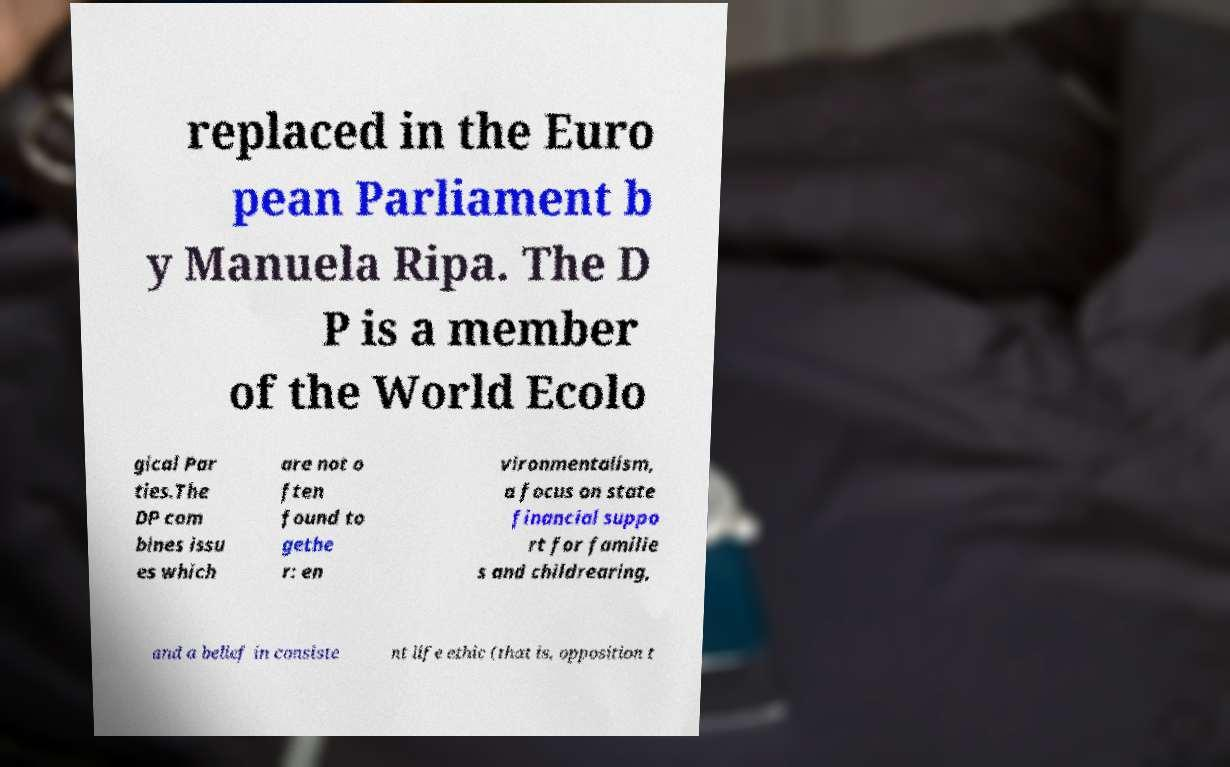Could you extract and type out the text from this image? replaced in the Euro pean Parliament b y Manuela Ripa. The D P is a member of the World Ecolo gical Par ties.The DP com bines issu es which are not o ften found to gethe r: en vironmentalism, a focus on state financial suppo rt for familie s and childrearing, and a belief in consiste nt life ethic (that is, opposition t 